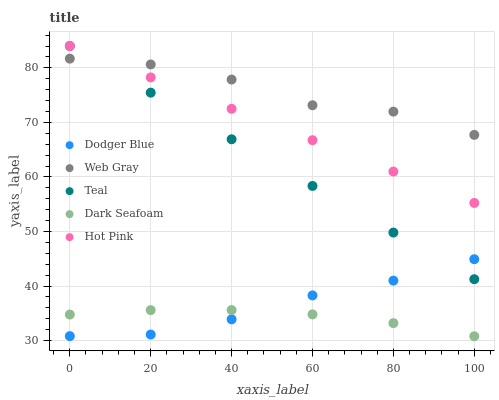Does Dark Seafoam have the minimum area under the curve?
Answer yes or no. Yes. Does Web Gray have the maximum area under the curve?
Answer yes or no. Yes. Does Dodger Blue have the minimum area under the curve?
Answer yes or no. No. Does Dodger Blue have the maximum area under the curve?
Answer yes or no. No. Is Hot Pink the smoothest?
Answer yes or no. Yes. Is Web Gray the roughest?
Answer yes or no. Yes. Is Dodger Blue the smoothest?
Answer yes or no. No. Is Dodger Blue the roughest?
Answer yes or no. No. Does Dark Seafoam have the lowest value?
Answer yes or no. Yes. Does Dodger Blue have the lowest value?
Answer yes or no. No. Does Hot Pink have the highest value?
Answer yes or no. Yes. Does Web Gray have the highest value?
Answer yes or no. No. Is Dark Seafoam less than Hot Pink?
Answer yes or no. Yes. Is Web Gray greater than Dark Seafoam?
Answer yes or no. Yes. Does Web Gray intersect Teal?
Answer yes or no. Yes. Is Web Gray less than Teal?
Answer yes or no. No. Is Web Gray greater than Teal?
Answer yes or no. No. Does Dark Seafoam intersect Hot Pink?
Answer yes or no. No. 